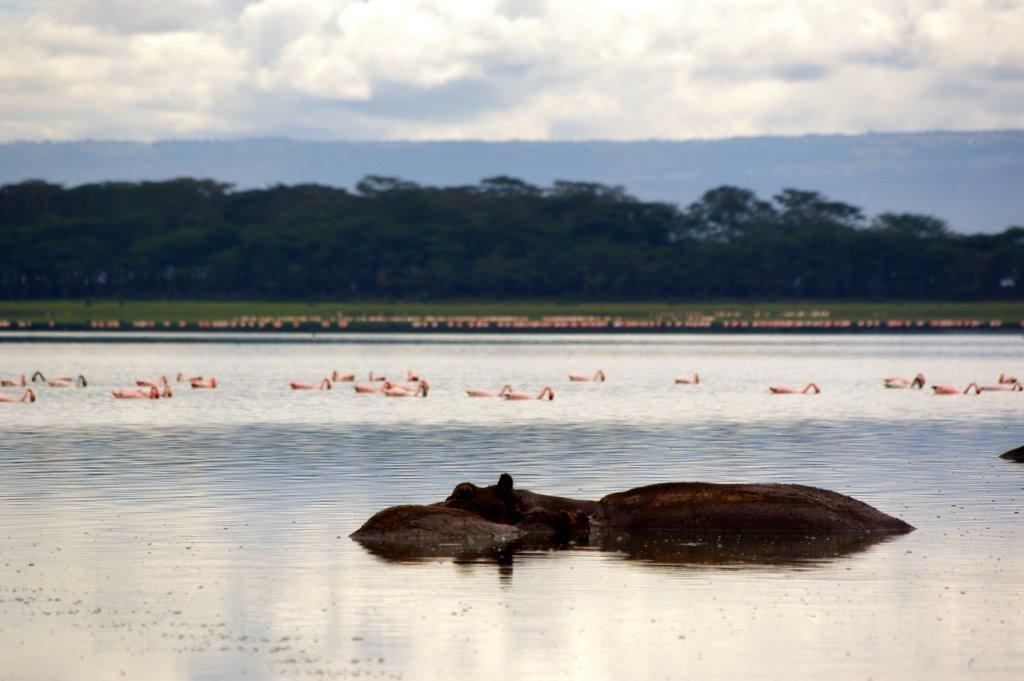What type of animals can be seen in the water in the image? There are animals in the water in the image. What can be seen in the background of the image? There are trees visible in the image. What is visible in the sky in the image? Clouds are present in the sky. Can you see a worm crawling on the tree in the image? There is no worm visible in the image; only animals in the water, trees, and clouds in the sky are present. 